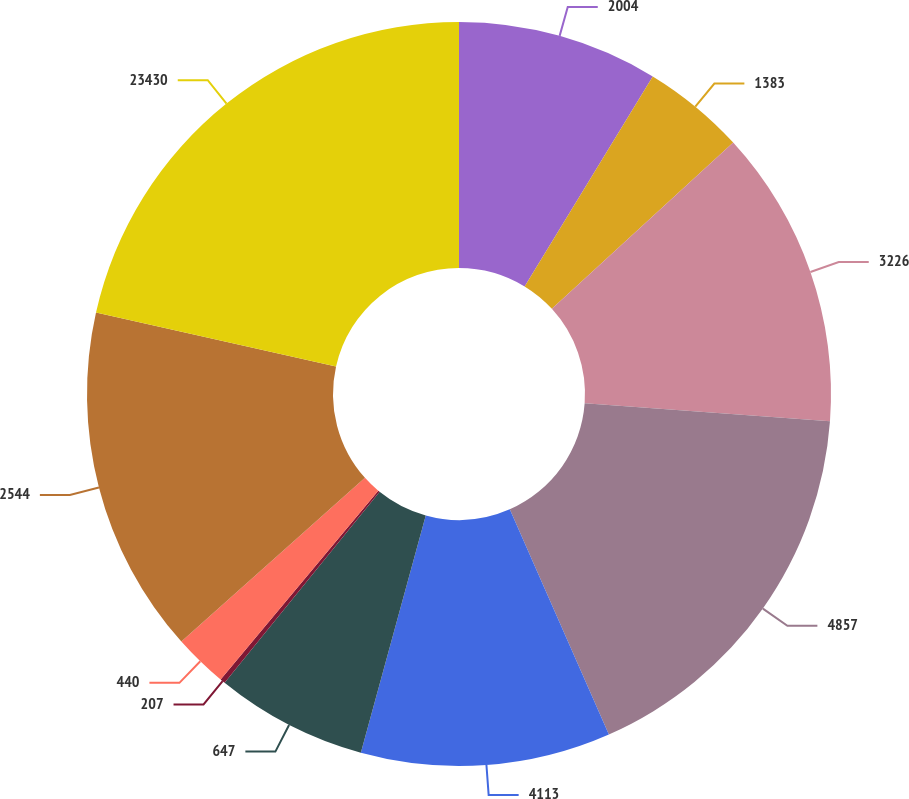Convert chart. <chart><loc_0><loc_0><loc_500><loc_500><pie_chart><fcel>2004<fcel>1383<fcel>3226<fcel>4857<fcel>4113<fcel>647<fcel>207<fcel>440<fcel>2544<fcel>23430<nl><fcel>8.72%<fcel>4.47%<fcel>12.98%<fcel>17.23%<fcel>10.85%<fcel>6.6%<fcel>0.22%<fcel>2.34%<fcel>15.1%<fcel>21.49%<nl></chart> 